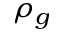<formula> <loc_0><loc_0><loc_500><loc_500>\rho _ { g }</formula> 